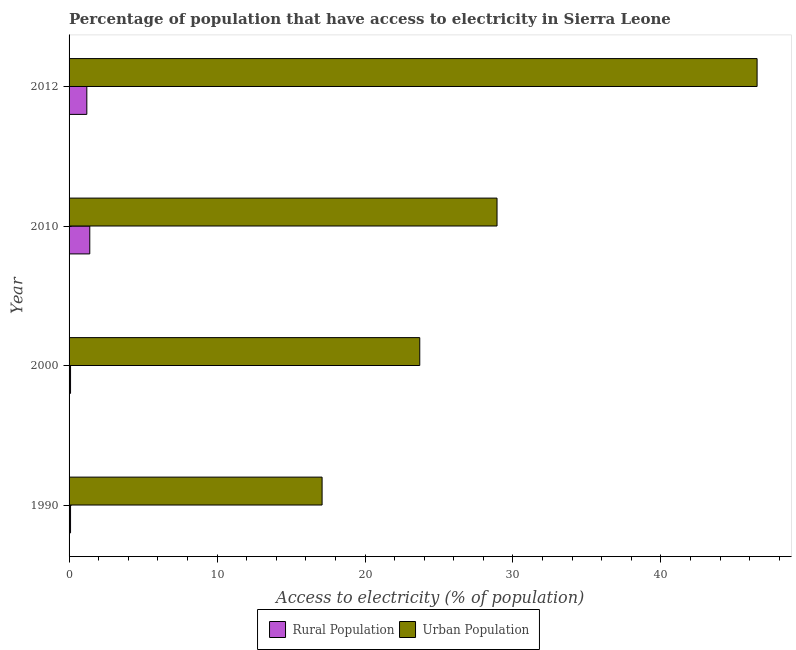How many different coloured bars are there?
Your response must be concise. 2. How many groups of bars are there?
Your response must be concise. 4. Are the number of bars per tick equal to the number of legend labels?
Give a very brief answer. Yes. In how many cases, is the number of bars for a given year not equal to the number of legend labels?
Your response must be concise. 0. What is the percentage of urban population having access to electricity in 2000?
Ensure brevity in your answer.  23.7. Across all years, what is the maximum percentage of rural population having access to electricity?
Provide a short and direct response. 1.4. Across all years, what is the minimum percentage of urban population having access to electricity?
Keep it short and to the point. 17.1. In which year was the percentage of urban population having access to electricity minimum?
Give a very brief answer. 1990. What is the difference between the percentage of rural population having access to electricity in 1990 and that in 2010?
Your response must be concise. -1.3. What is the difference between the percentage of rural population having access to electricity in 2000 and the percentage of urban population having access to electricity in 2010?
Your response must be concise. -28.82. What is the average percentage of rural population having access to electricity per year?
Your response must be concise. 0.7. In the year 2012, what is the difference between the percentage of urban population having access to electricity and percentage of rural population having access to electricity?
Offer a very short reply. 45.3. In how many years, is the percentage of rural population having access to electricity greater than 4 %?
Make the answer very short. 0. What is the ratio of the percentage of rural population having access to electricity in 1990 to that in 2012?
Keep it short and to the point. 0.08. Is the percentage of urban population having access to electricity in 1990 less than that in 2012?
Provide a short and direct response. Yes. What is the difference between the highest and the second highest percentage of urban population having access to electricity?
Offer a terse response. 17.58. What is the difference between the highest and the lowest percentage of rural population having access to electricity?
Ensure brevity in your answer.  1.3. What does the 1st bar from the top in 1990 represents?
Your response must be concise. Urban Population. What does the 2nd bar from the bottom in 2010 represents?
Ensure brevity in your answer.  Urban Population. How many bars are there?
Your answer should be compact. 8. Are the values on the major ticks of X-axis written in scientific E-notation?
Make the answer very short. No. Where does the legend appear in the graph?
Your response must be concise. Bottom center. How many legend labels are there?
Keep it short and to the point. 2. How are the legend labels stacked?
Your answer should be compact. Horizontal. What is the title of the graph?
Make the answer very short. Percentage of population that have access to electricity in Sierra Leone. Does "Domestic liabilities" appear as one of the legend labels in the graph?
Your answer should be compact. No. What is the label or title of the X-axis?
Provide a short and direct response. Access to electricity (% of population). What is the Access to electricity (% of population) in Urban Population in 1990?
Give a very brief answer. 17.1. What is the Access to electricity (% of population) in Rural Population in 2000?
Your answer should be compact. 0.1. What is the Access to electricity (% of population) of Urban Population in 2000?
Offer a terse response. 23.7. What is the Access to electricity (% of population) in Rural Population in 2010?
Provide a succinct answer. 1.4. What is the Access to electricity (% of population) of Urban Population in 2010?
Provide a succinct answer. 28.92. What is the Access to electricity (% of population) of Rural Population in 2012?
Keep it short and to the point. 1.2. What is the Access to electricity (% of population) of Urban Population in 2012?
Give a very brief answer. 46.5. Across all years, what is the maximum Access to electricity (% of population) in Rural Population?
Your answer should be compact. 1.4. Across all years, what is the maximum Access to electricity (% of population) of Urban Population?
Your answer should be very brief. 46.5. Across all years, what is the minimum Access to electricity (% of population) of Urban Population?
Keep it short and to the point. 17.1. What is the total Access to electricity (% of population) of Urban Population in the graph?
Ensure brevity in your answer.  116.23. What is the difference between the Access to electricity (% of population) in Urban Population in 1990 and that in 2000?
Ensure brevity in your answer.  -6.6. What is the difference between the Access to electricity (% of population) of Urban Population in 1990 and that in 2010?
Offer a very short reply. -11.82. What is the difference between the Access to electricity (% of population) in Urban Population in 1990 and that in 2012?
Your answer should be very brief. -29.4. What is the difference between the Access to electricity (% of population) of Rural Population in 2000 and that in 2010?
Offer a very short reply. -1.3. What is the difference between the Access to electricity (% of population) of Urban Population in 2000 and that in 2010?
Give a very brief answer. -5.22. What is the difference between the Access to electricity (% of population) of Urban Population in 2000 and that in 2012?
Offer a very short reply. -22.8. What is the difference between the Access to electricity (% of population) of Urban Population in 2010 and that in 2012?
Your response must be concise. -17.58. What is the difference between the Access to electricity (% of population) of Rural Population in 1990 and the Access to electricity (% of population) of Urban Population in 2000?
Your answer should be compact. -23.6. What is the difference between the Access to electricity (% of population) of Rural Population in 1990 and the Access to electricity (% of population) of Urban Population in 2010?
Provide a succinct answer. -28.82. What is the difference between the Access to electricity (% of population) of Rural Population in 1990 and the Access to electricity (% of population) of Urban Population in 2012?
Make the answer very short. -46.4. What is the difference between the Access to electricity (% of population) of Rural Population in 2000 and the Access to electricity (% of population) of Urban Population in 2010?
Provide a succinct answer. -28.82. What is the difference between the Access to electricity (% of population) of Rural Population in 2000 and the Access to electricity (% of population) of Urban Population in 2012?
Provide a short and direct response. -46.4. What is the difference between the Access to electricity (% of population) in Rural Population in 2010 and the Access to electricity (% of population) in Urban Population in 2012?
Offer a very short reply. -45.1. What is the average Access to electricity (% of population) of Urban Population per year?
Make the answer very short. 29.06. In the year 1990, what is the difference between the Access to electricity (% of population) in Rural Population and Access to electricity (% of population) in Urban Population?
Ensure brevity in your answer.  -17. In the year 2000, what is the difference between the Access to electricity (% of population) of Rural Population and Access to electricity (% of population) of Urban Population?
Provide a short and direct response. -23.6. In the year 2010, what is the difference between the Access to electricity (% of population) of Rural Population and Access to electricity (% of population) of Urban Population?
Make the answer very short. -27.52. In the year 2012, what is the difference between the Access to electricity (% of population) of Rural Population and Access to electricity (% of population) of Urban Population?
Keep it short and to the point. -45.3. What is the ratio of the Access to electricity (% of population) of Rural Population in 1990 to that in 2000?
Offer a very short reply. 1. What is the ratio of the Access to electricity (% of population) of Urban Population in 1990 to that in 2000?
Your answer should be compact. 0.72. What is the ratio of the Access to electricity (% of population) in Rural Population in 1990 to that in 2010?
Keep it short and to the point. 0.07. What is the ratio of the Access to electricity (% of population) in Urban Population in 1990 to that in 2010?
Give a very brief answer. 0.59. What is the ratio of the Access to electricity (% of population) of Rural Population in 1990 to that in 2012?
Offer a terse response. 0.08. What is the ratio of the Access to electricity (% of population) in Urban Population in 1990 to that in 2012?
Your response must be concise. 0.37. What is the ratio of the Access to electricity (% of population) in Rural Population in 2000 to that in 2010?
Offer a very short reply. 0.07. What is the ratio of the Access to electricity (% of population) of Urban Population in 2000 to that in 2010?
Offer a terse response. 0.82. What is the ratio of the Access to electricity (% of population) of Rural Population in 2000 to that in 2012?
Your response must be concise. 0.08. What is the ratio of the Access to electricity (% of population) of Urban Population in 2000 to that in 2012?
Offer a terse response. 0.51. What is the ratio of the Access to electricity (% of population) in Urban Population in 2010 to that in 2012?
Offer a very short reply. 0.62. What is the difference between the highest and the second highest Access to electricity (% of population) of Rural Population?
Your response must be concise. 0.2. What is the difference between the highest and the second highest Access to electricity (% of population) of Urban Population?
Offer a very short reply. 17.58. What is the difference between the highest and the lowest Access to electricity (% of population) of Urban Population?
Offer a very short reply. 29.4. 